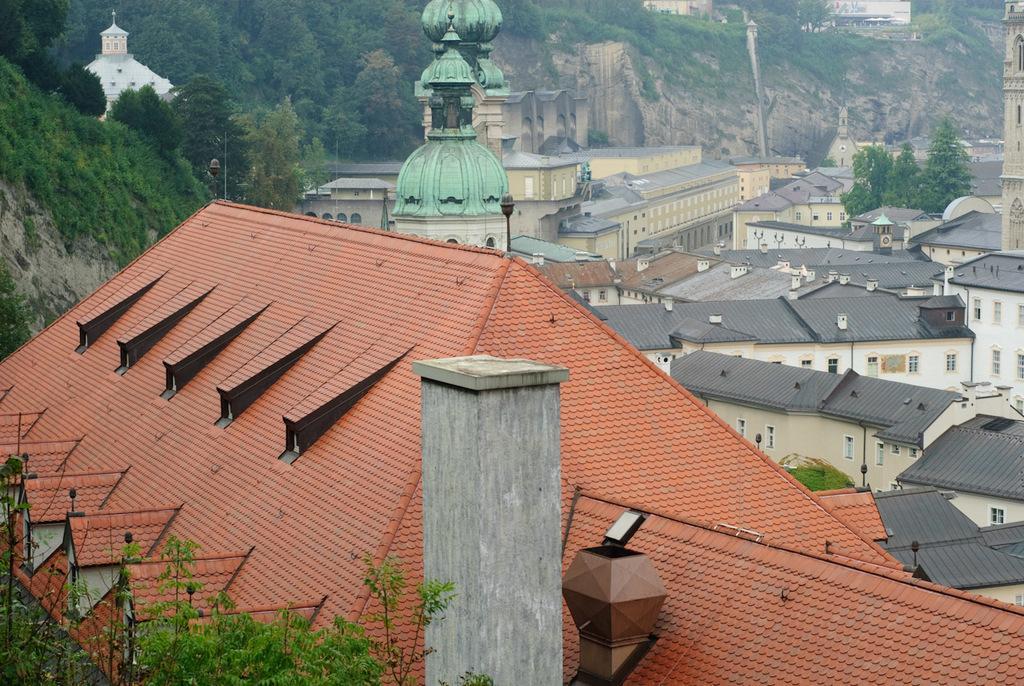Describe this image in one or two sentences. In this image I can see few buildings in brown, cream and green color. In the background I can see few trees in green color. 